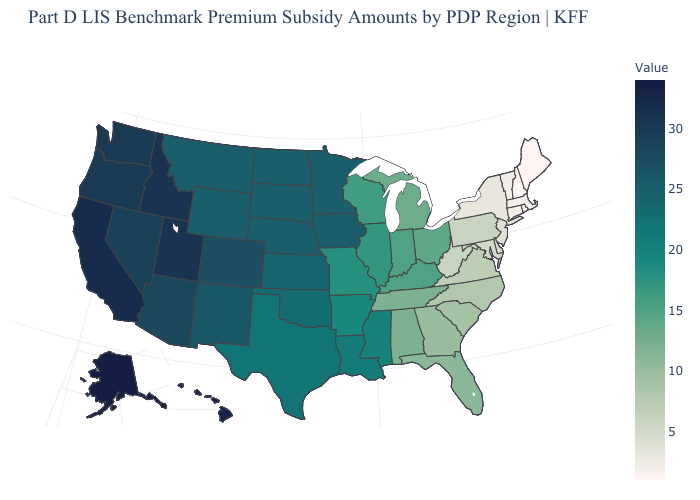Among the states that border Wisconsin , does Iowa have the highest value?
Write a very short answer. Yes. Among the states that border Ohio , which have the highest value?
Concise answer only. Indiana, Kentucky. Does the map have missing data?
Keep it brief. No. Does Montana have a higher value than Nevada?
Be succinct. No. Does the map have missing data?
Keep it brief. No. Is the legend a continuous bar?
Give a very brief answer. Yes. 